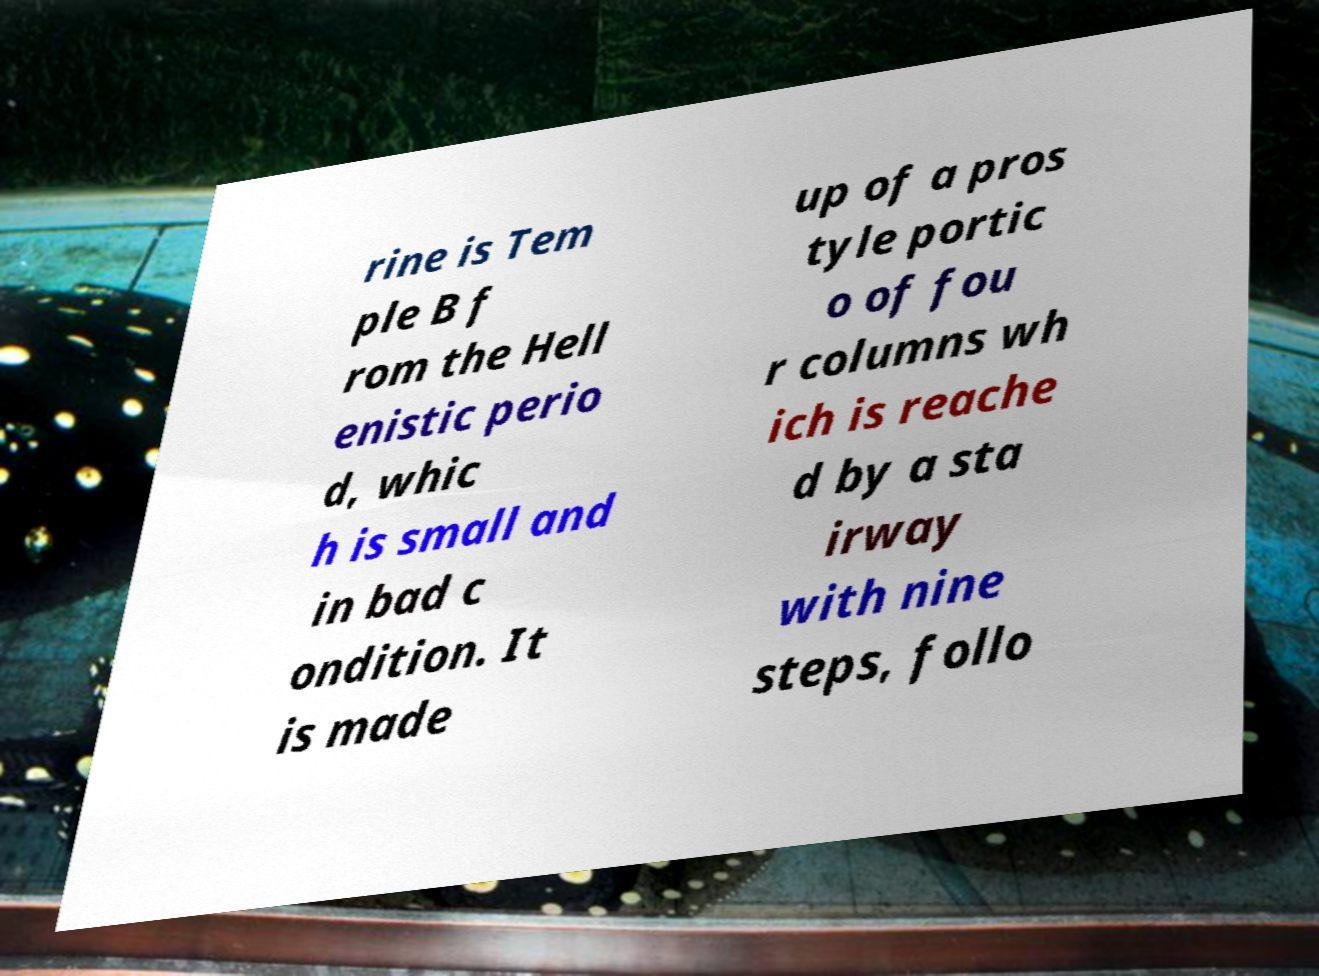For documentation purposes, I need the text within this image transcribed. Could you provide that? rine is Tem ple B f rom the Hell enistic perio d, whic h is small and in bad c ondition. It is made up of a pros tyle portic o of fou r columns wh ich is reache d by a sta irway with nine steps, follo 